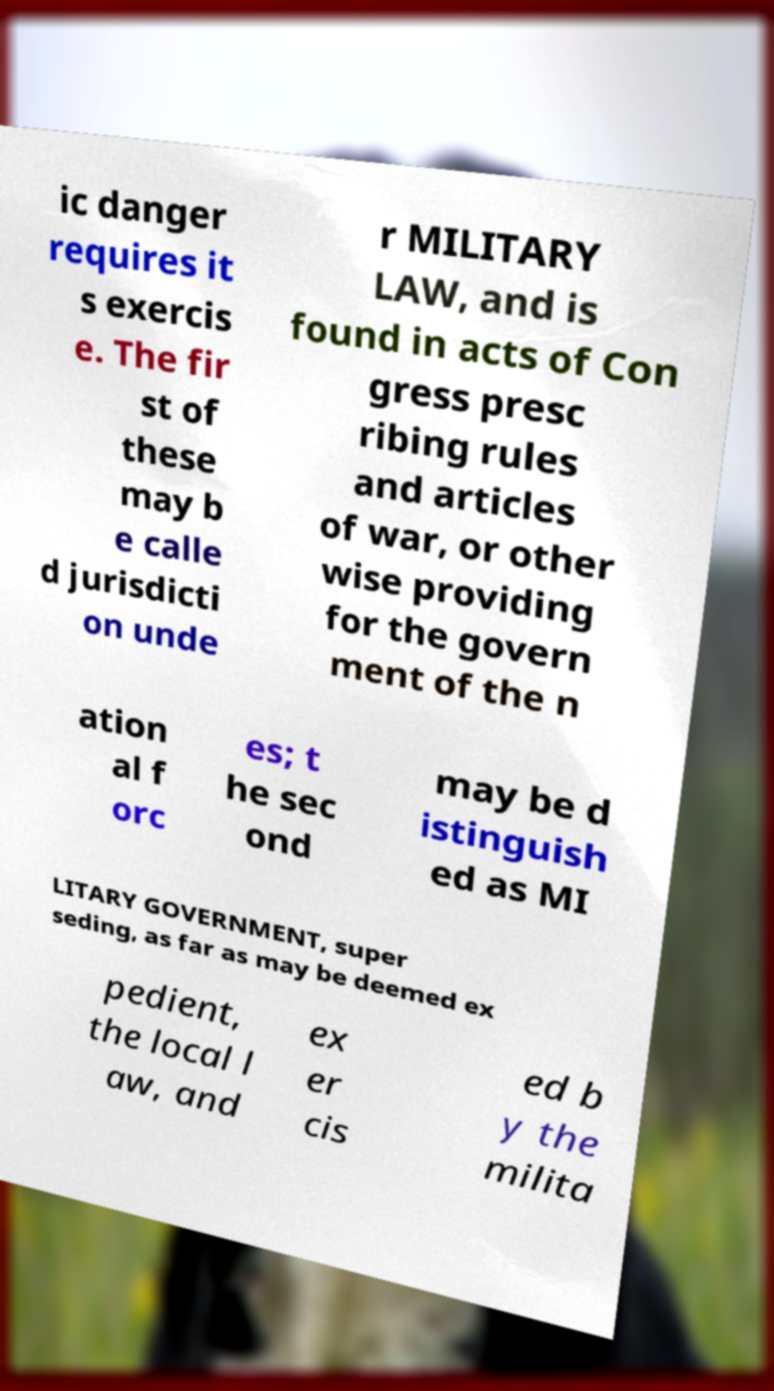Could you extract and type out the text from this image? ic danger requires it s exercis e. The fir st of these may b e calle d jurisdicti on unde r MILITARY LAW, and is found in acts of Con gress presc ribing rules and articles of war, or other wise providing for the govern ment of the n ation al f orc es; t he sec ond may be d istinguish ed as MI LITARY GOVERNMENT, super seding, as far as may be deemed ex pedient, the local l aw, and ex er cis ed b y the milita 